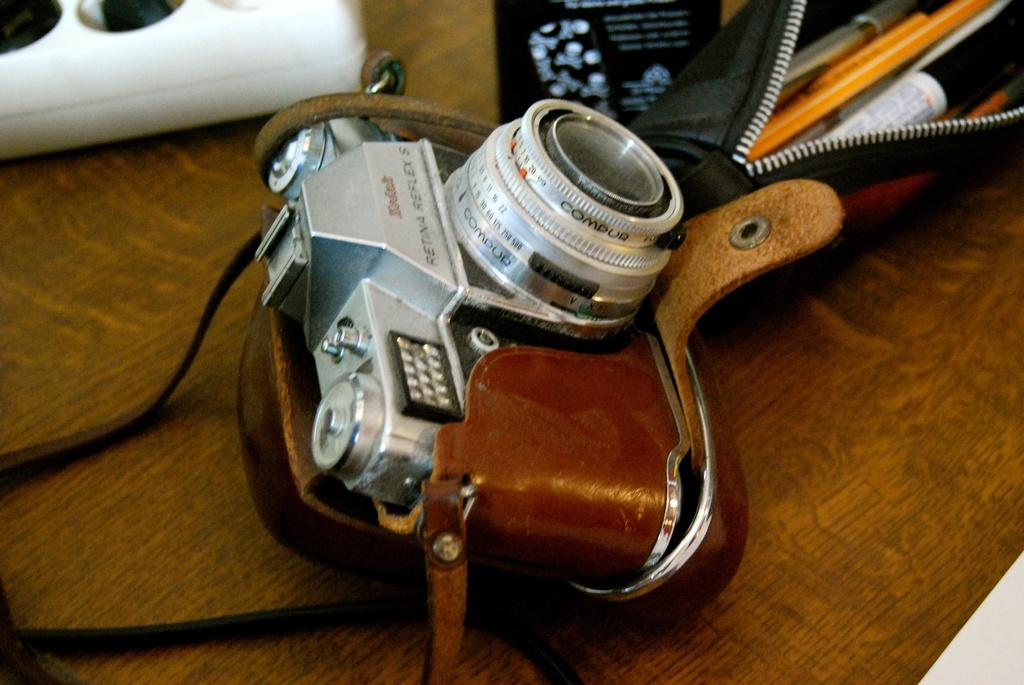What is the main object in the image? There is a camera in the image. What items can be found in the pouch in the image? There are pens and pencils in a pouch in the image. What is the surface where the pouch and other objects are placed? There are other objects placed on a table in the image. Can you see the eye of the farmer in the image? There is no farmer or eye present in the image. What type of game is being played in the image? There is no game or play depicted in the image. 